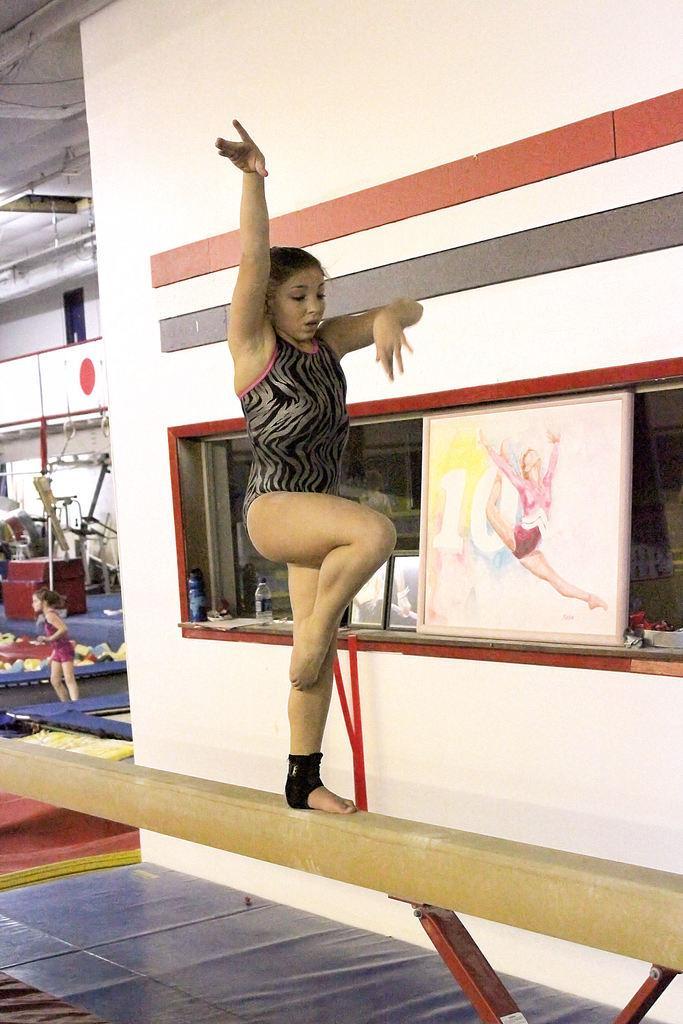Can you describe this image briefly? In this image there is a woman standing on a stick. Behind her there is a wall. There is a frame on the wall. To the left there is another woman standing. At the top there is the ceiling. 